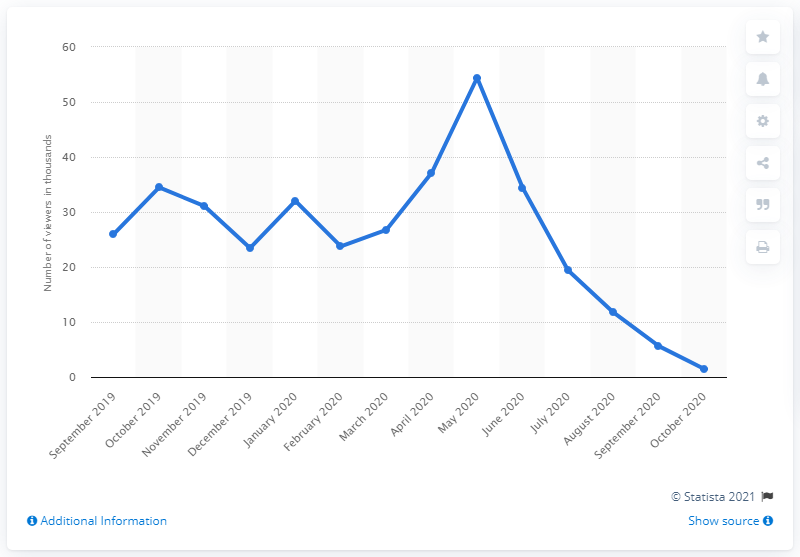List a handful of essential elements in this visual. FIFA 20 was released in September 2019. 